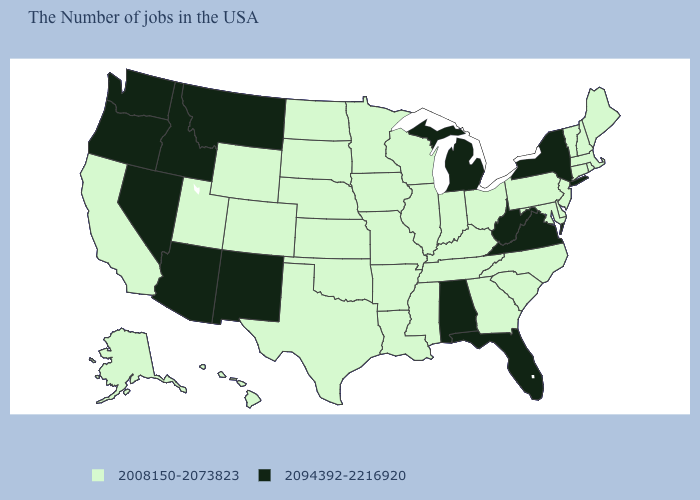What is the value of Georgia?
Keep it brief. 2008150-2073823. Does California have a higher value than Montana?
Quick response, please. No. What is the value of New Jersey?
Answer briefly. 2008150-2073823. Name the states that have a value in the range 2094392-2216920?
Quick response, please. New York, Virginia, West Virginia, Florida, Michigan, Alabama, New Mexico, Montana, Arizona, Idaho, Nevada, Washington, Oregon. Does the first symbol in the legend represent the smallest category?
Answer briefly. Yes. How many symbols are there in the legend?
Short answer required. 2. What is the value of Iowa?
Write a very short answer. 2008150-2073823. Does the first symbol in the legend represent the smallest category?
Be succinct. Yes. Among the states that border Arkansas , which have the highest value?
Answer briefly. Tennessee, Mississippi, Louisiana, Missouri, Oklahoma, Texas. What is the highest value in the USA?
Quick response, please. 2094392-2216920. Among the states that border Arizona , does Nevada have the highest value?
Give a very brief answer. Yes. Among the states that border Vermont , does New York have the lowest value?
Concise answer only. No. What is the value of Oregon?
Be succinct. 2094392-2216920. What is the lowest value in the West?
Short answer required. 2008150-2073823. What is the value of Oklahoma?
Keep it brief. 2008150-2073823. 